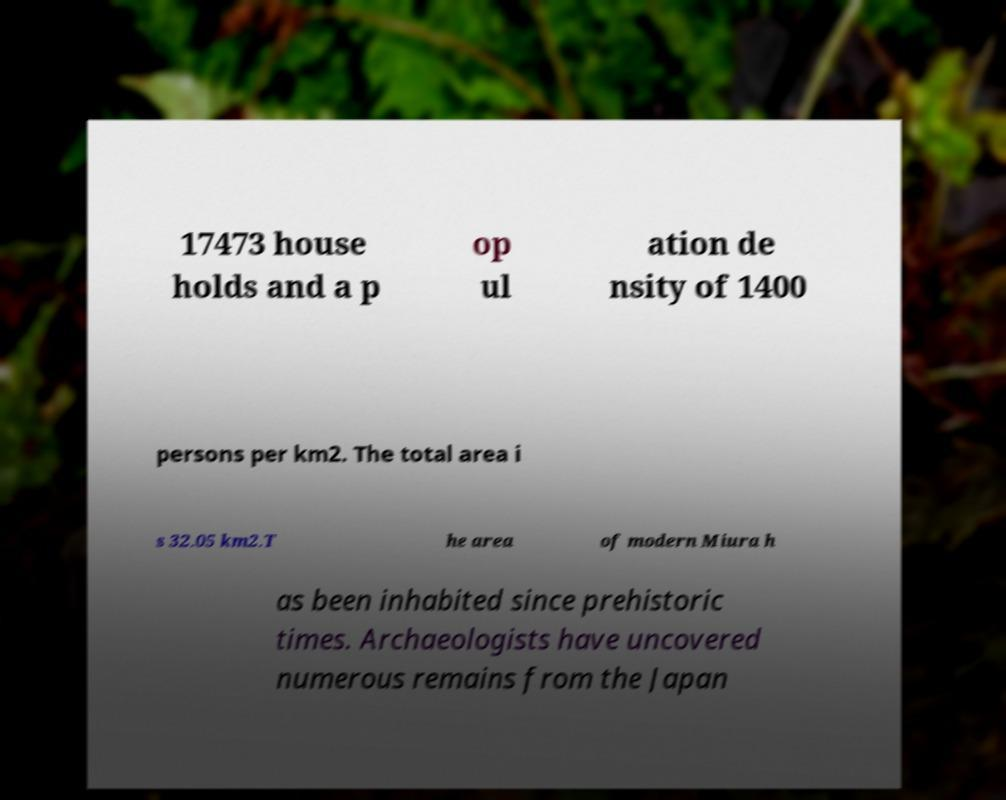What messages or text are displayed in this image? I need them in a readable, typed format. 17473 house holds and a p op ul ation de nsity of 1400 persons per km2. The total area i s 32.05 km2.T he area of modern Miura h as been inhabited since prehistoric times. Archaeologists have uncovered numerous remains from the Japan 